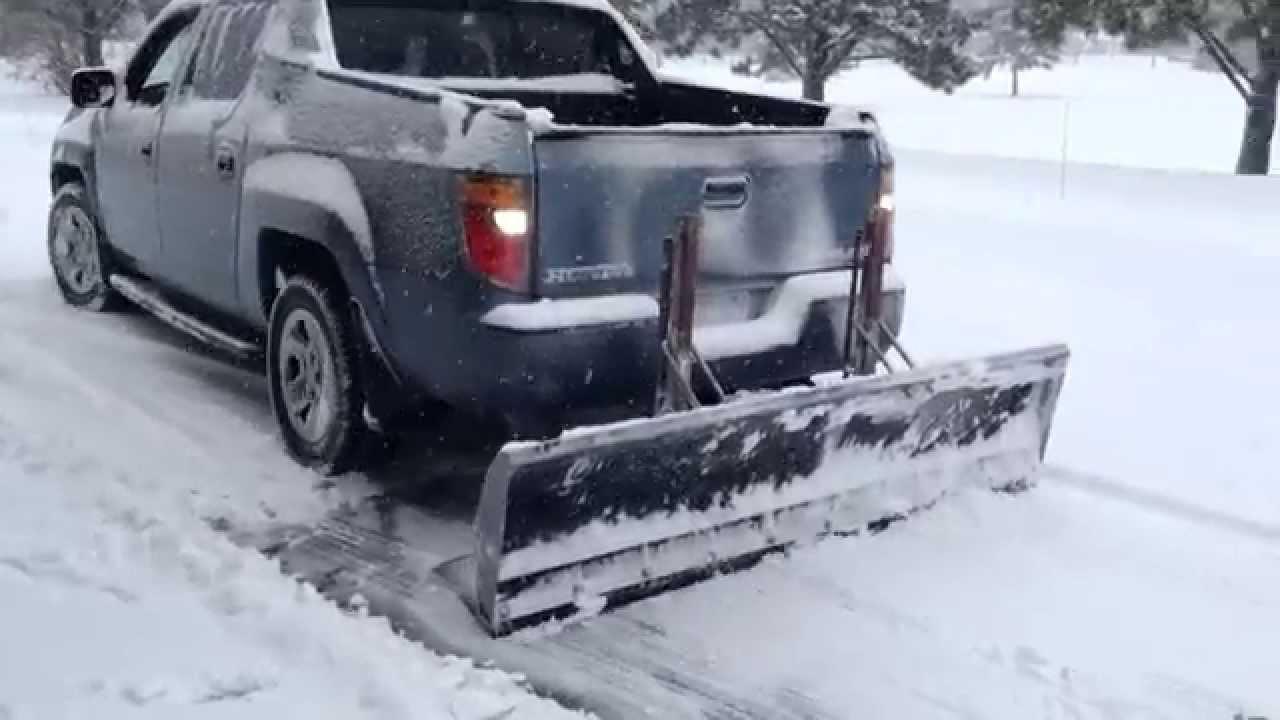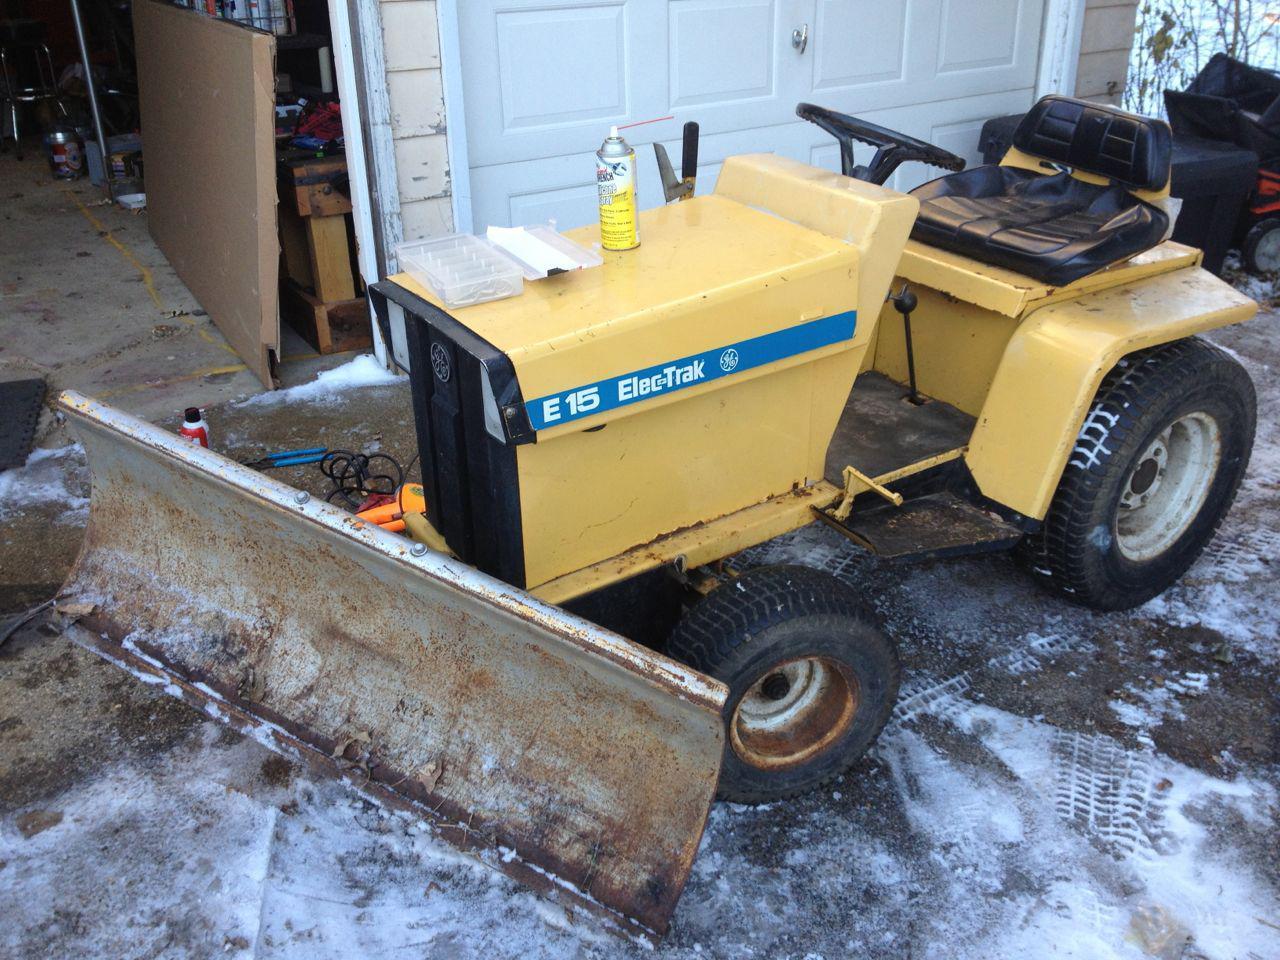The first image is the image on the left, the second image is the image on the right. For the images shown, is this caption "An image shows a dark pickup truck pulling a plow on a snowy street." true? Answer yes or no. Yes. The first image is the image on the left, the second image is the image on the right. Considering the images on both sides, is "In one image, a pickup truck with rear mounted snow blade is on a snow covered street." valid? Answer yes or no. Yes. 